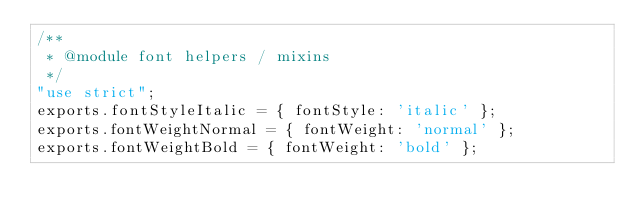Convert code to text. <code><loc_0><loc_0><loc_500><loc_500><_JavaScript_>/**
 * @module font helpers / mixins
 */
"use strict";
exports.fontStyleItalic = { fontStyle: 'italic' };
exports.fontWeightNormal = { fontWeight: 'normal' };
exports.fontWeightBold = { fontWeight: 'bold' };
</code> 